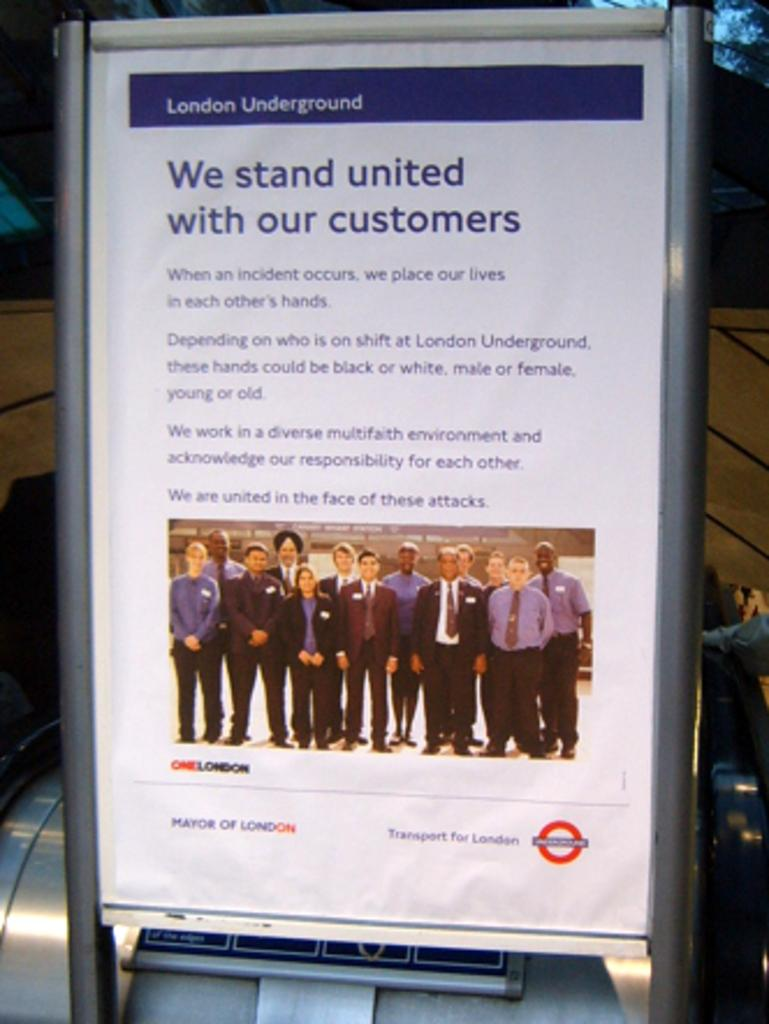Provide a one-sentence caption for the provided image. An advertisement message from employees of the London Underground gives assurance to customers. 